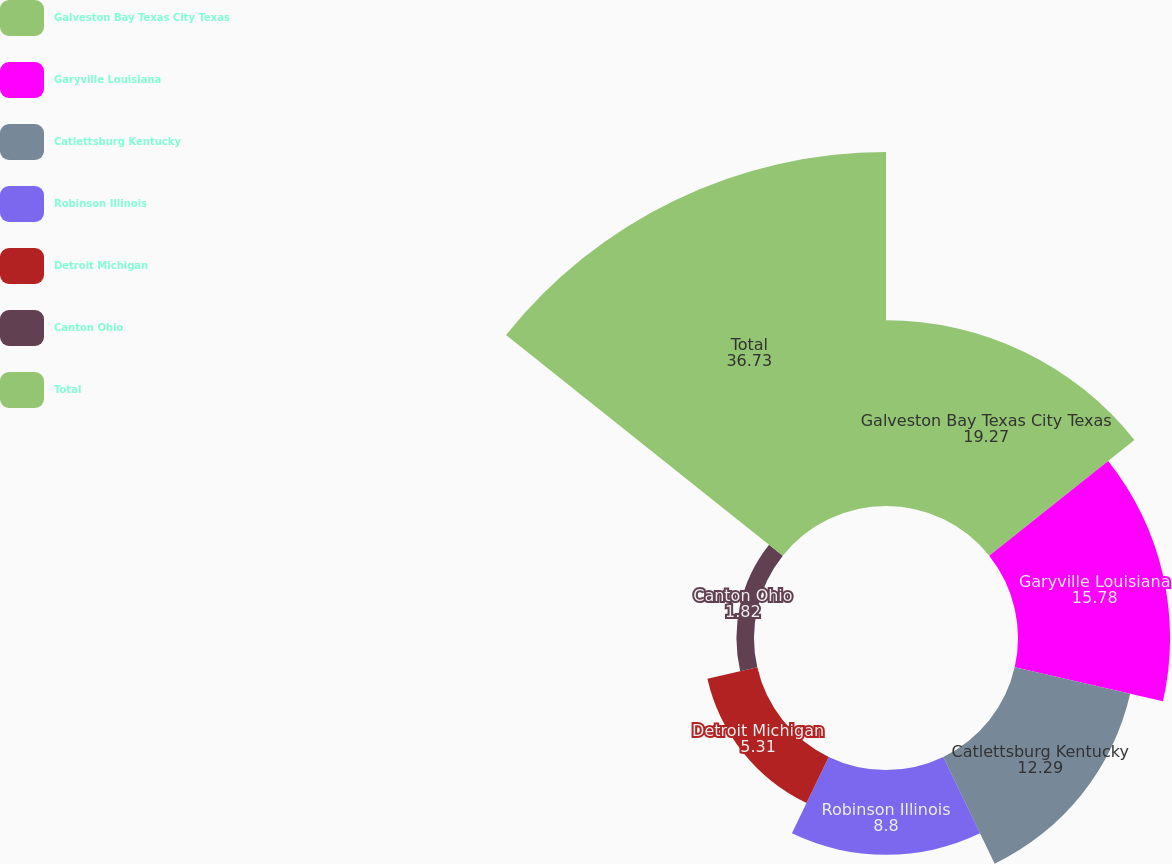<chart> <loc_0><loc_0><loc_500><loc_500><pie_chart><fcel>Galveston Bay Texas City Texas<fcel>Garyville Louisiana<fcel>Catlettsburg Kentucky<fcel>Robinson Illinois<fcel>Detroit Michigan<fcel>Canton Ohio<fcel>Total<nl><fcel>19.27%<fcel>15.78%<fcel>12.29%<fcel>8.8%<fcel>5.31%<fcel>1.82%<fcel>36.73%<nl></chart> 